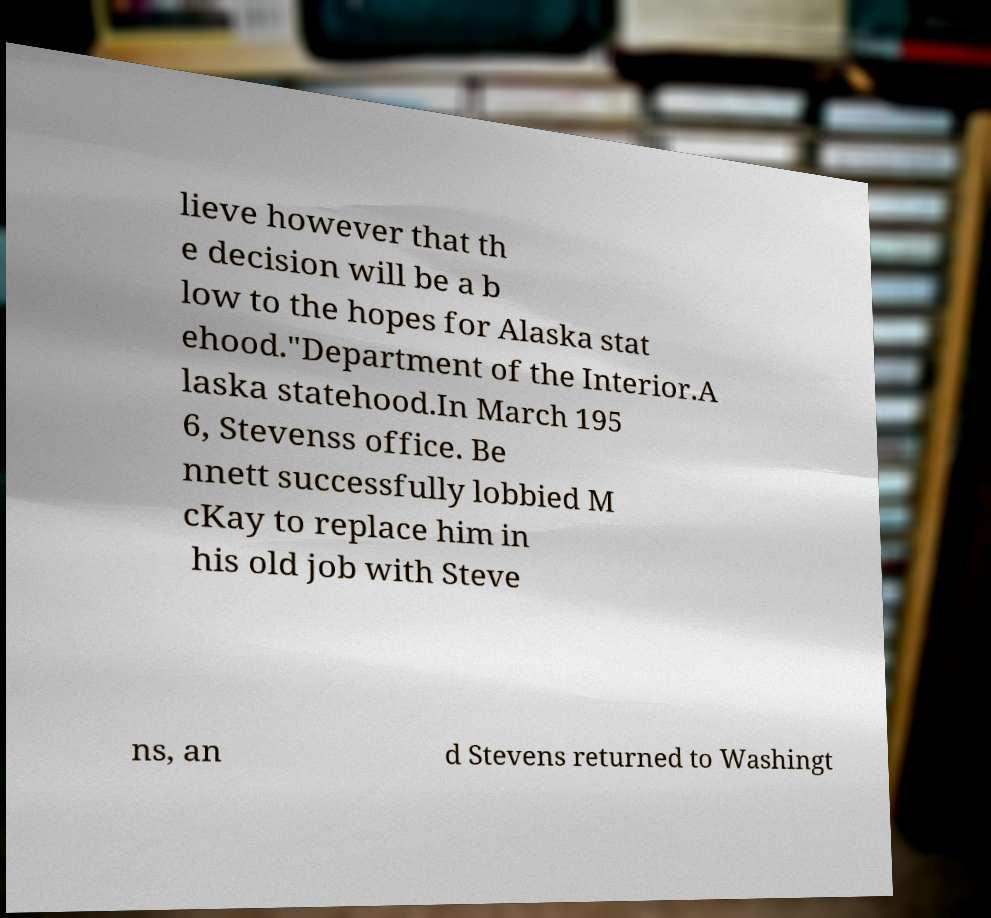Can you read and provide the text displayed in the image?This photo seems to have some interesting text. Can you extract and type it out for me? lieve however that th e decision will be a b low to the hopes for Alaska stat ehood."Department of the Interior.A laska statehood.In March 195 6, Stevenss office. Be nnett successfully lobbied M cKay to replace him in his old job with Steve ns, an d Stevens returned to Washingt 